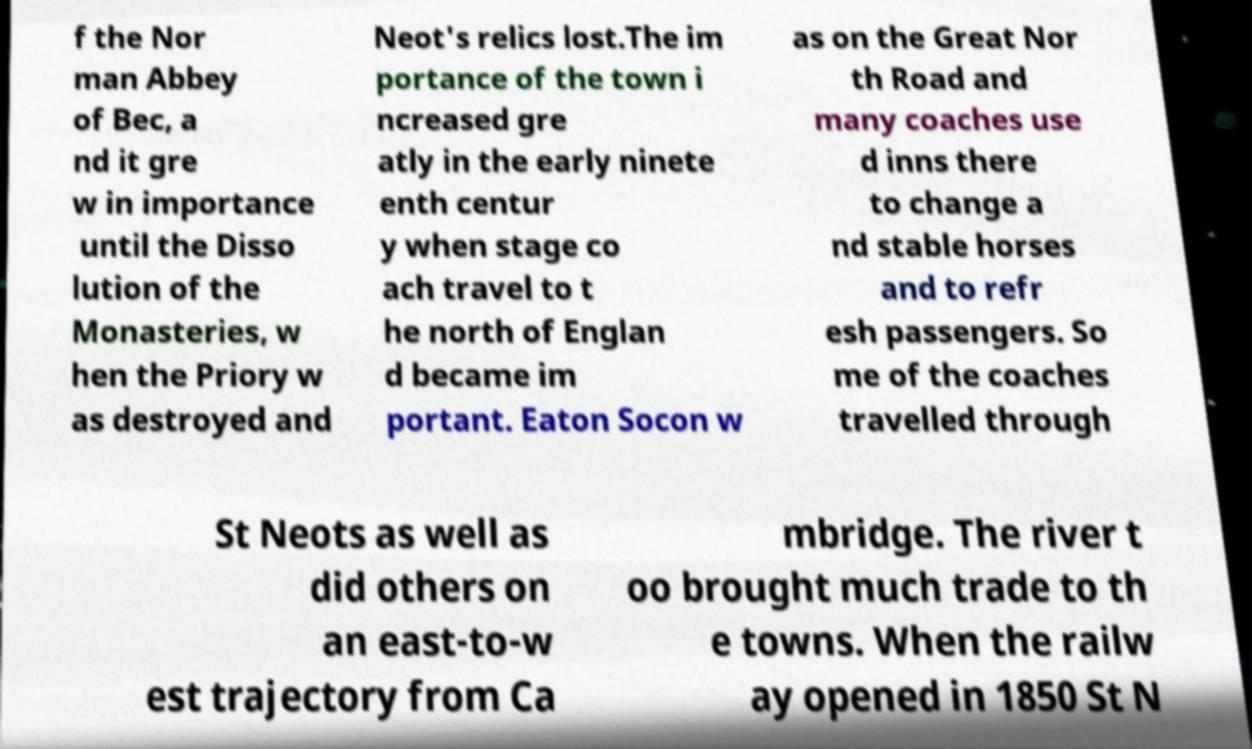I need the written content from this picture converted into text. Can you do that? f the Nor man Abbey of Bec, a nd it gre w in importance until the Disso lution of the Monasteries, w hen the Priory w as destroyed and Neot's relics lost.The im portance of the town i ncreased gre atly in the early ninete enth centur y when stage co ach travel to t he north of Englan d became im portant. Eaton Socon w as on the Great Nor th Road and many coaches use d inns there to change a nd stable horses and to refr esh passengers. So me of the coaches travelled through St Neots as well as did others on an east-to-w est trajectory from Ca mbridge. The river t oo brought much trade to th e towns. When the railw ay opened in 1850 St N 